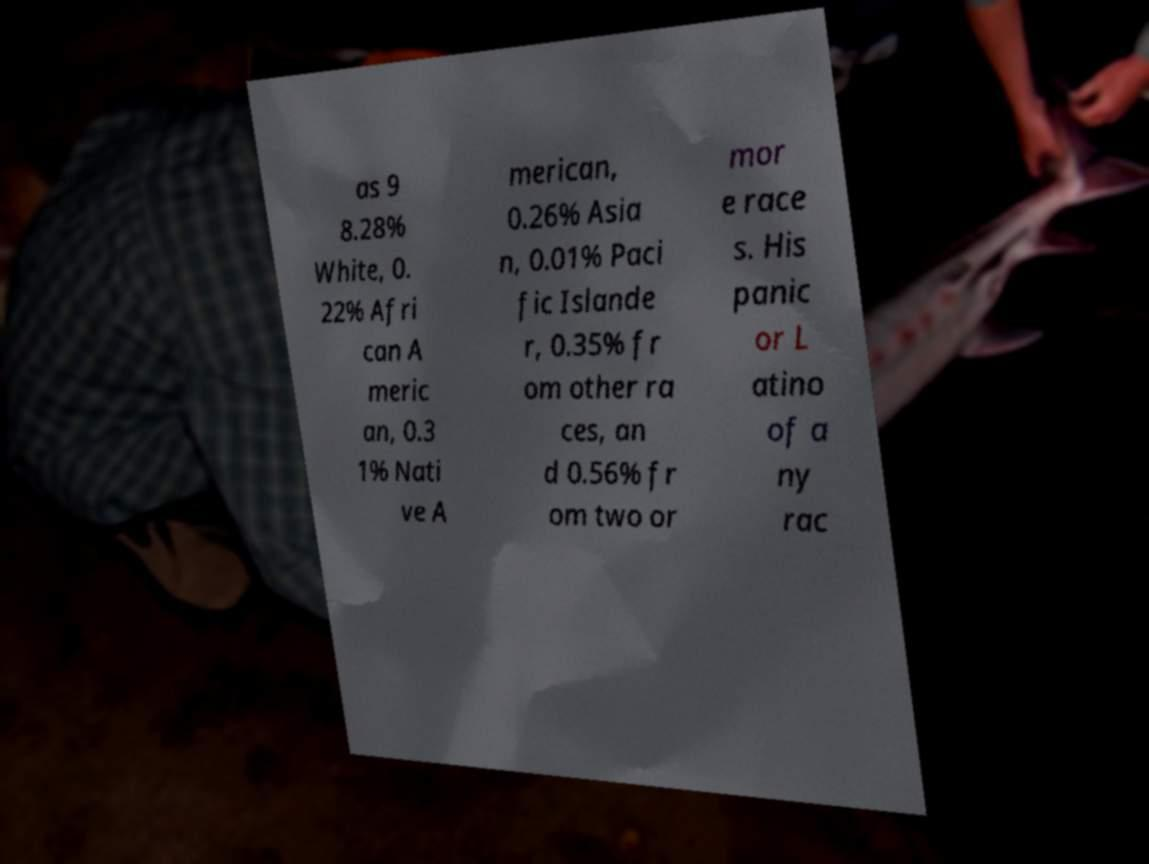For documentation purposes, I need the text within this image transcribed. Could you provide that? as 9 8.28% White, 0. 22% Afri can A meric an, 0.3 1% Nati ve A merican, 0.26% Asia n, 0.01% Paci fic Islande r, 0.35% fr om other ra ces, an d 0.56% fr om two or mor e race s. His panic or L atino of a ny rac 